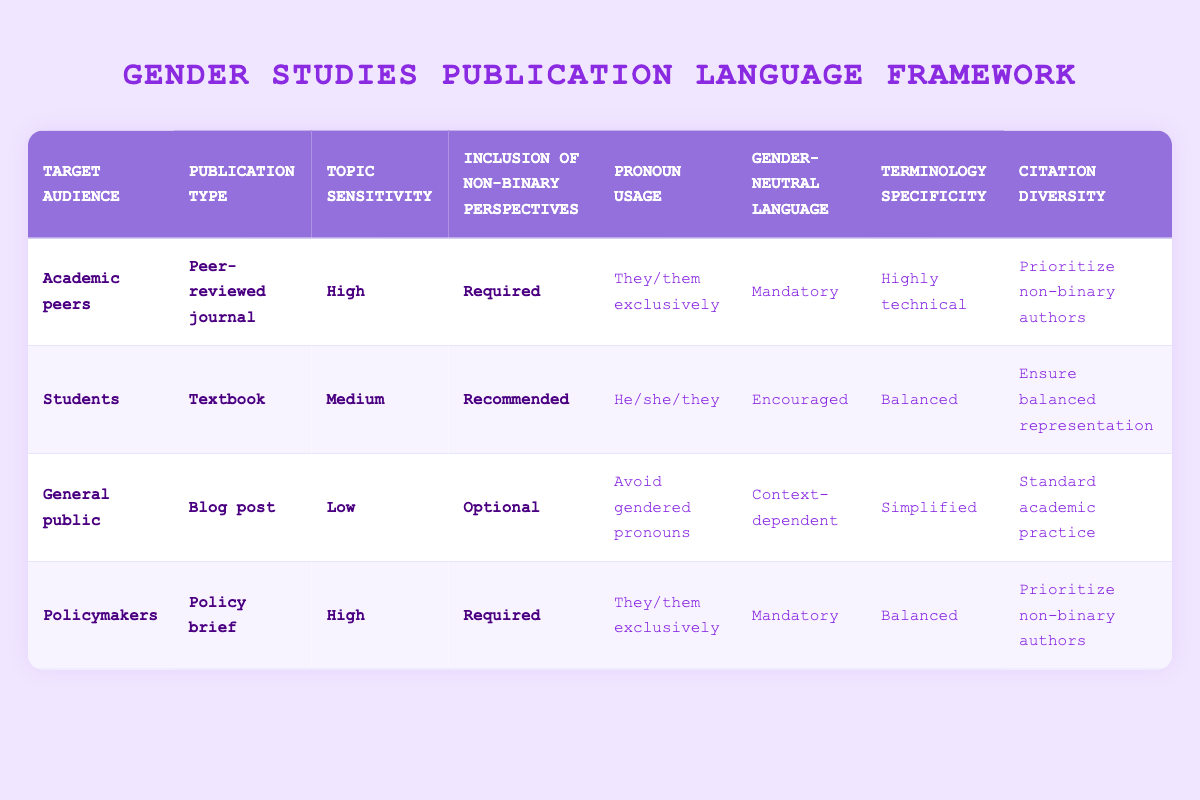What are the pronouns recommended for general public blog posts? According to the table, for blog posts aimed at the general public, the recommended pronoun usage is "Avoid gendered pronouns."
Answer: Avoid gendered pronouns Which audience type is associated with highly technical terminology? The table shows that "Academic peers" in a "Peer-reviewed journal" with "High" topic sensitivity and "Required" inclusion of non-binary perspectives is associated with "Highly technical" terminology.
Answer: Academic peers Is it mandatory to use gender-neutral language for policymakers? The table indicates that for policymakers in a "Policy brief" with a "High" topic sensitivity and "Required" inclusion of non-binary perspectives, the use of gender-neutral language is "Mandatory." Therefore, the answer is yes.
Answer: Yes What is the main difference in pronoun usage between students' textbooks and policymakers' briefs? For students' textbooks, the pronoun usage is "He/she/they," while for policymakers' briefs, it is "They/them exclusively." So the main difference is the exclusive usage of they/them for policymakers and a mix of he/she/they for students.
Answer: Exclusive they/them vs. he/she/they How many publication types recommend avoiding gendered pronouns? The table shows that only one publication type - the blog post for the general public - recommends "Avoid gendered pronouns." Therefore, the total is one.
Answer: One If a publication is targeted at academic peers, what is the expected approach to citation diversity? The table indicates that for "Academic peers," the citation diversity should "Prioritize non-binary authors" when the publication is a "Peer-reviewed journal" with "High" topic sensitivity and "Required" inclusion of non-binary perspectives.
Answer: Prioritize non-binary authors For a textbook aimed at students, how is gender-neutral language treated? The table shows that for textbooks aimed at students, gender-neutral language is "Encouraged" when the topic sensitivity is "Medium" and inclusion of non-binary perspectives is "Recommended."
Answer: Encouraged What is the overall theme for the action suggestions related to policymakers? The actions for policymakers in a policy brief with high sensitivity and required non-binary perspectives consistently call for "They/them exclusively" for pronoun usage, "Mandatory" gender-neutral language, "Balanced" terminology specificity, and "Prioritize non-binary authors" for citation diversity. This integrates a strong focus on inclusivity.
Answer: Inclusion and mandatory language use 